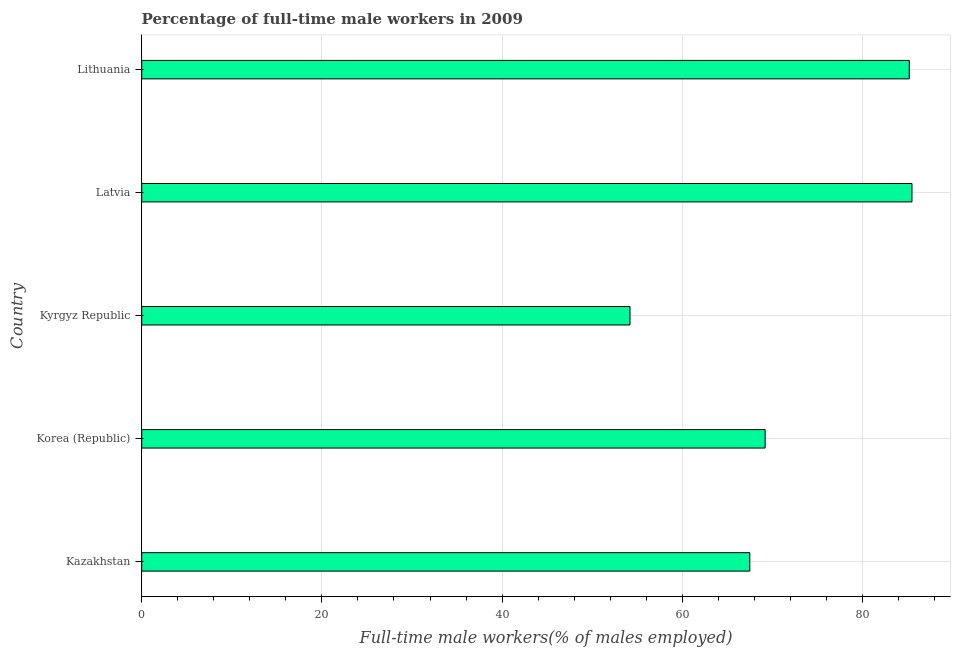Does the graph contain any zero values?
Your answer should be very brief. No. What is the title of the graph?
Your answer should be compact. Percentage of full-time male workers in 2009. What is the label or title of the X-axis?
Provide a short and direct response. Full-time male workers(% of males employed). What is the percentage of full-time male workers in Latvia?
Offer a terse response. 85.5. Across all countries, what is the maximum percentage of full-time male workers?
Keep it short and to the point. 85.5. Across all countries, what is the minimum percentage of full-time male workers?
Offer a very short reply. 54.2. In which country was the percentage of full-time male workers maximum?
Ensure brevity in your answer.  Latvia. In which country was the percentage of full-time male workers minimum?
Your response must be concise. Kyrgyz Republic. What is the sum of the percentage of full-time male workers?
Your answer should be compact. 361.6. What is the difference between the percentage of full-time male workers in Korea (Republic) and Latvia?
Keep it short and to the point. -16.3. What is the average percentage of full-time male workers per country?
Keep it short and to the point. 72.32. What is the median percentage of full-time male workers?
Your response must be concise. 69.2. What is the ratio of the percentage of full-time male workers in Kyrgyz Republic to that in Lithuania?
Your response must be concise. 0.64. Is the sum of the percentage of full-time male workers in Kazakhstan and Kyrgyz Republic greater than the maximum percentage of full-time male workers across all countries?
Provide a short and direct response. Yes. What is the difference between the highest and the lowest percentage of full-time male workers?
Keep it short and to the point. 31.3. How many bars are there?
Provide a succinct answer. 5. How many countries are there in the graph?
Your answer should be very brief. 5. Are the values on the major ticks of X-axis written in scientific E-notation?
Provide a succinct answer. No. What is the Full-time male workers(% of males employed) of Kazakhstan?
Ensure brevity in your answer.  67.5. What is the Full-time male workers(% of males employed) of Korea (Republic)?
Provide a succinct answer. 69.2. What is the Full-time male workers(% of males employed) in Kyrgyz Republic?
Make the answer very short. 54.2. What is the Full-time male workers(% of males employed) of Latvia?
Offer a terse response. 85.5. What is the Full-time male workers(% of males employed) in Lithuania?
Make the answer very short. 85.2. What is the difference between the Full-time male workers(% of males employed) in Kazakhstan and Korea (Republic)?
Give a very brief answer. -1.7. What is the difference between the Full-time male workers(% of males employed) in Kazakhstan and Kyrgyz Republic?
Make the answer very short. 13.3. What is the difference between the Full-time male workers(% of males employed) in Kazakhstan and Latvia?
Provide a succinct answer. -18. What is the difference between the Full-time male workers(% of males employed) in Kazakhstan and Lithuania?
Give a very brief answer. -17.7. What is the difference between the Full-time male workers(% of males employed) in Korea (Republic) and Latvia?
Ensure brevity in your answer.  -16.3. What is the difference between the Full-time male workers(% of males employed) in Kyrgyz Republic and Latvia?
Your answer should be very brief. -31.3. What is the difference between the Full-time male workers(% of males employed) in Kyrgyz Republic and Lithuania?
Offer a terse response. -31. What is the ratio of the Full-time male workers(% of males employed) in Kazakhstan to that in Kyrgyz Republic?
Provide a short and direct response. 1.25. What is the ratio of the Full-time male workers(% of males employed) in Kazakhstan to that in Latvia?
Offer a terse response. 0.79. What is the ratio of the Full-time male workers(% of males employed) in Kazakhstan to that in Lithuania?
Ensure brevity in your answer.  0.79. What is the ratio of the Full-time male workers(% of males employed) in Korea (Republic) to that in Kyrgyz Republic?
Provide a succinct answer. 1.28. What is the ratio of the Full-time male workers(% of males employed) in Korea (Republic) to that in Latvia?
Offer a terse response. 0.81. What is the ratio of the Full-time male workers(% of males employed) in Korea (Republic) to that in Lithuania?
Keep it short and to the point. 0.81. What is the ratio of the Full-time male workers(% of males employed) in Kyrgyz Republic to that in Latvia?
Your answer should be very brief. 0.63. What is the ratio of the Full-time male workers(% of males employed) in Kyrgyz Republic to that in Lithuania?
Provide a succinct answer. 0.64. 